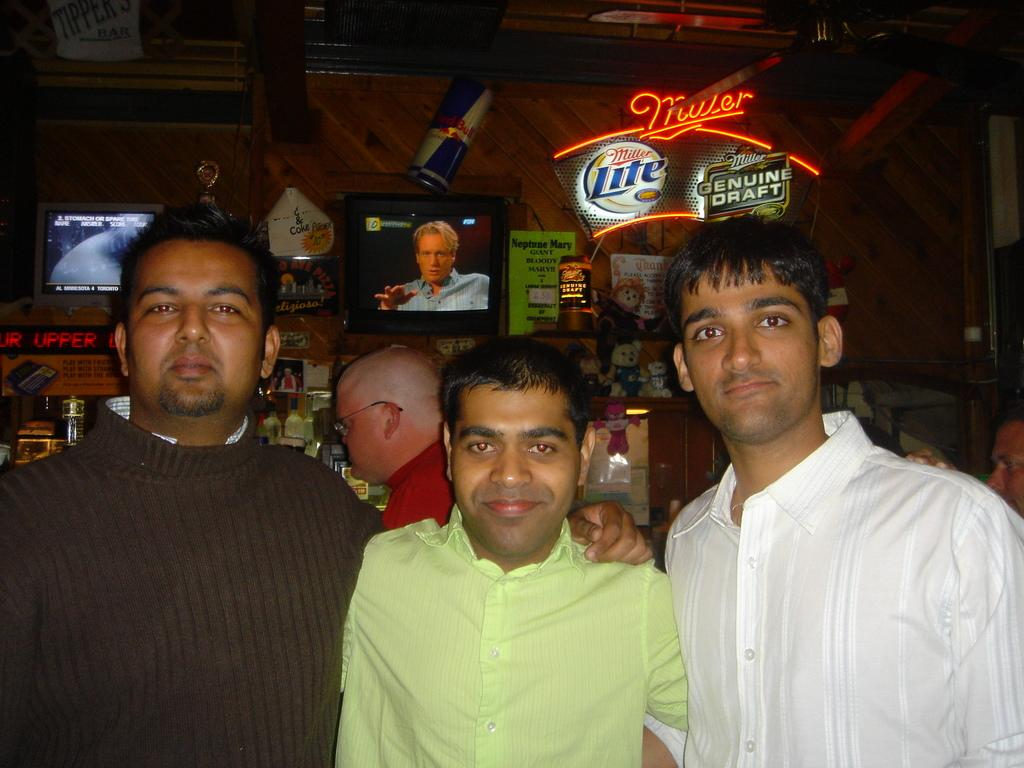How many people are present in the image? There are three people in the image. What is the facial expression of the people in the image? The people are smiling. Can you describe the background of the image? There are people, televisions, a wall, and some objects in the background of the image. What color is the cloud in the image? There is no cloud present in the image. How does the paint on the wall appear in the image? There is no paint mentioned in the image; only a wall is described. 